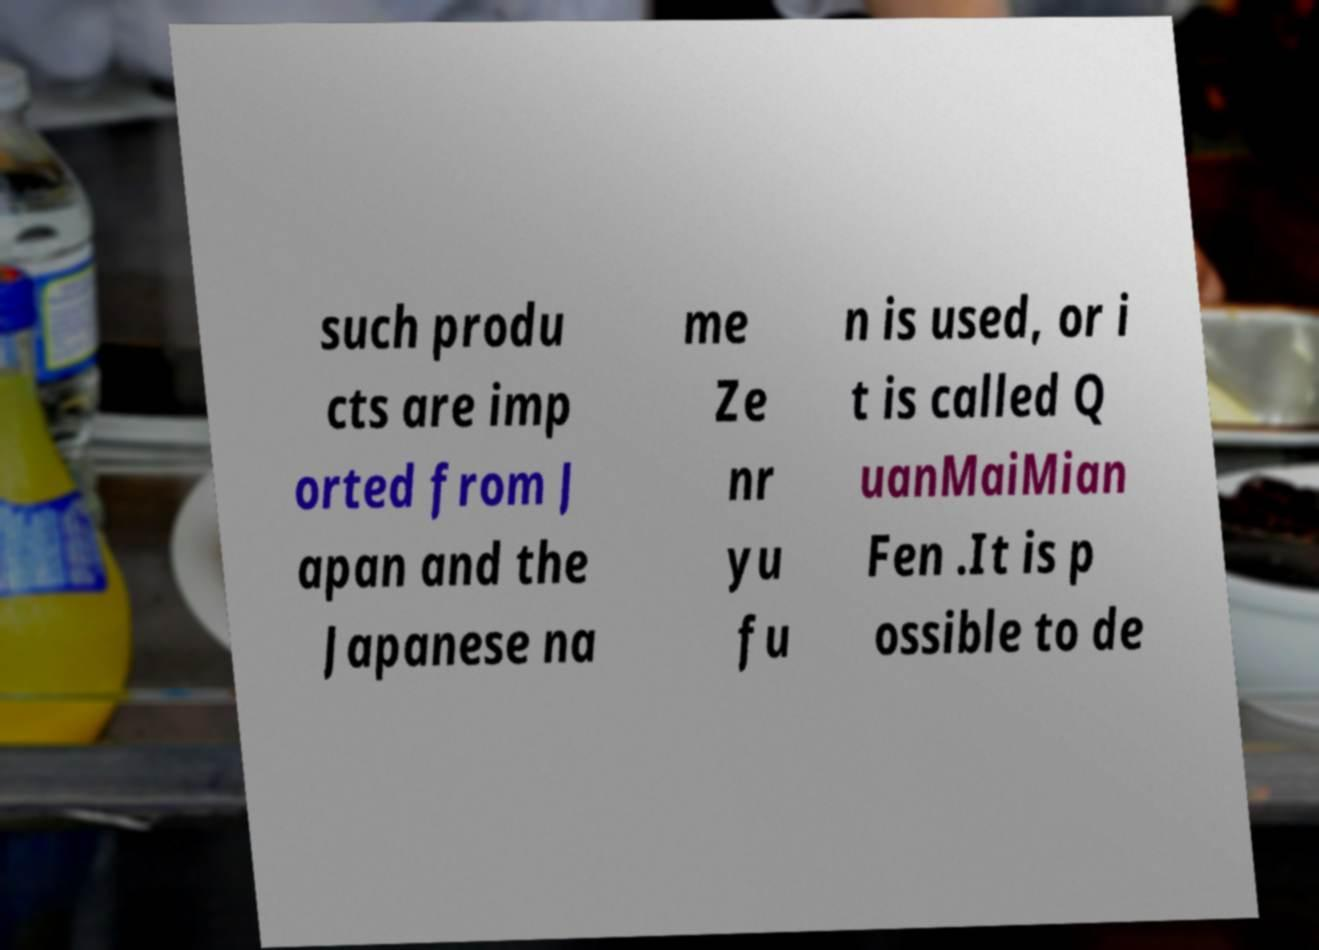There's text embedded in this image that I need extracted. Can you transcribe it verbatim? such produ cts are imp orted from J apan and the Japanese na me Ze nr yu fu n is used, or i t is called Q uanMaiMian Fen .It is p ossible to de 